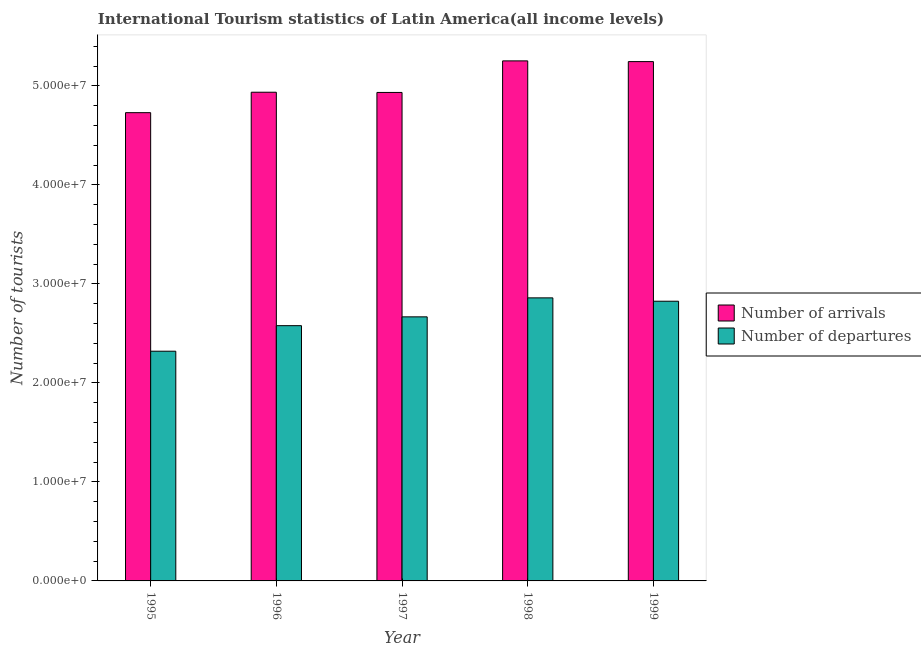What is the label of the 4th group of bars from the left?
Your response must be concise. 1998. What is the number of tourist departures in 1998?
Provide a succinct answer. 2.86e+07. Across all years, what is the maximum number of tourist arrivals?
Give a very brief answer. 5.25e+07. Across all years, what is the minimum number of tourist departures?
Your answer should be very brief. 2.32e+07. In which year was the number of tourist arrivals minimum?
Your response must be concise. 1995. What is the total number of tourist arrivals in the graph?
Provide a short and direct response. 2.51e+08. What is the difference between the number of tourist arrivals in 1995 and that in 1997?
Offer a very short reply. -2.04e+06. What is the difference between the number of tourist departures in 1996 and the number of tourist arrivals in 1995?
Your answer should be very brief. 2.58e+06. What is the average number of tourist arrivals per year?
Your answer should be compact. 5.02e+07. In the year 1998, what is the difference between the number of tourist departures and number of tourist arrivals?
Your answer should be very brief. 0. In how many years, is the number of tourist departures greater than 10000000?
Give a very brief answer. 5. What is the ratio of the number of tourist arrivals in 1998 to that in 1999?
Make the answer very short. 1. Is the number of tourist arrivals in 1995 less than that in 1999?
Make the answer very short. Yes. What is the difference between the highest and the second highest number of tourist arrivals?
Provide a short and direct response. 7.27e+04. What is the difference between the highest and the lowest number of tourist arrivals?
Provide a succinct answer. 5.23e+06. What does the 1st bar from the left in 1998 represents?
Your answer should be very brief. Number of arrivals. What does the 1st bar from the right in 1998 represents?
Your response must be concise. Number of departures. How many bars are there?
Offer a terse response. 10. What is the difference between two consecutive major ticks on the Y-axis?
Offer a very short reply. 1.00e+07. Are the values on the major ticks of Y-axis written in scientific E-notation?
Provide a short and direct response. Yes. Does the graph contain grids?
Provide a short and direct response. No. Where does the legend appear in the graph?
Make the answer very short. Center right. What is the title of the graph?
Give a very brief answer. International Tourism statistics of Latin America(all income levels). What is the label or title of the X-axis?
Your response must be concise. Year. What is the label or title of the Y-axis?
Provide a short and direct response. Number of tourists. What is the Number of tourists of Number of arrivals in 1995?
Your response must be concise. 4.73e+07. What is the Number of tourists of Number of departures in 1995?
Keep it short and to the point. 2.32e+07. What is the Number of tourists of Number of arrivals in 1996?
Make the answer very short. 4.94e+07. What is the Number of tourists in Number of departures in 1996?
Give a very brief answer. 2.58e+07. What is the Number of tourists of Number of arrivals in 1997?
Give a very brief answer. 4.93e+07. What is the Number of tourists in Number of departures in 1997?
Your response must be concise. 2.67e+07. What is the Number of tourists of Number of arrivals in 1998?
Keep it short and to the point. 5.25e+07. What is the Number of tourists in Number of departures in 1998?
Your answer should be compact. 2.86e+07. What is the Number of tourists of Number of arrivals in 1999?
Offer a very short reply. 5.25e+07. What is the Number of tourists of Number of departures in 1999?
Ensure brevity in your answer.  2.83e+07. Across all years, what is the maximum Number of tourists in Number of arrivals?
Give a very brief answer. 5.25e+07. Across all years, what is the maximum Number of tourists in Number of departures?
Offer a terse response. 2.86e+07. Across all years, what is the minimum Number of tourists of Number of arrivals?
Offer a terse response. 4.73e+07. Across all years, what is the minimum Number of tourists in Number of departures?
Keep it short and to the point. 2.32e+07. What is the total Number of tourists of Number of arrivals in the graph?
Keep it short and to the point. 2.51e+08. What is the total Number of tourists in Number of departures in the graph?
Offer a terse response. 1.33e+08. What is the difference between the Number of tourists of Number of arrivals in 1995 and that in 1996?
Your response must be concise. -2.06e+06. What is the difference between the Number of tourists in Number of departures in 1995 and that in 1996?
Make the answer very short. -2.58e+06. What is the difference between the Number of tourists of Number of arrivals in 1995 and that in 1997?
Provide a succinct answer. -2.04e+06. What is the difference between the Number of tourists in Number of departures in 1995 and that in 1997?
Ensure brevity in your answer.  -3.47e+06. What is the difference between the Number of tourists of Number of arrivals in 1995 and that in 1998?
Your answer should be very brief. -5.23e+06. What is the difference between the Number of tourists in Number of departures in 1995 and that in 1998?
Give a very brief answer. -5.39e+06. What is the difference between the Number of tourists of Number of arrivals in 1995 and that in 1999?
Keep it short and to the point. -5.16e+06. What is the difference between the Number of tourists in Number of departures in 1995 and that in 1999?
Provide a short and direct response. -5.05e+06. What is the difference between the Number of tourists in Number of arrivals in 1996 and that in 1997?
Provide a short and direct response. 2.15e+04. What is the difference between the Number of tourists of Number of departures in 1996 and that in 1997?
Your answer should be compact. -8.90e+05. What is the difference between the Number of tourists in Number of arrivals in 1996 and that in 1998?
Make the answer very short. -3.17e+06. What is the difference between the Number of tourists in Number of departures in 1996 and that in 1998?
Your answer should be very brief. -2.81e+06. What is the difference between the Number of tourists of Number of arrivals in 1996 and that in 1999?
Make the answer very short. -3.09e+06. What is the difference between the Number of tourists in Number of departures in 1996 and that in 1999?
Keep it short and to the point. -2.47e+06. What is the difference between the Number of tourists in Number of arrivals in 1997 and that in 1998?
Keep it short and to the point. -3.19e+06. What is the difference between the Number of tourists in Number of departures in 1997 and that in 1998?
Keep it short and to the point. -1.92e+06. What is the difference between the Number of tourists in Number of arrivals in 1997 and that in 1999?
Ensure brevity in your answer.  -3.12e+06. What is the difference between the Number of tourists in Number of departures in 1997 and that in 1999?
Provide a succinct answer. -1.58e+06. What is the difference between the Number of tourists of Number of arrivals in 1998 and that in 1999?
Keep it short and to the point. 7.27e+04. What is the difference between the Number of tourists in Number of departures in 1998 and that in 1999?
Provide a short and direct response. 3.40e+05. What is the difference between the Number of tourists of Number of arrivals in 1995 and the Number of tourists of Number of departures in 1996?
Offer a terse response. 2.15e+07. What is the difference between the Number of tourists in Number of arrivals in 1995 and the Number of tourists in Number of departures in 1997?
Your answer should be very brief. 2.06e+07. What is the difference between the Number of tourists of Number of arrivals in 1995 and the Number of tourists of Number of departures in 1998?
Provide a succinct answer. 1.87e+07. What is the difference between the Number of tourists in Number of arrivals in 1995 and the Number of tourists in Number of departures in 1999?
Offer a terse response. 1.90e+07. What is the difference between the Number of tourists in Number of arrivals in 1996 and the Number of tourists in Number of departures in 1997?
Offer a very short reply. 2.27e+07. What is the difference between the Number of tourists of Number of arrivals in 1996 and the Number of tourists of Number of departures in 1998?
Your answer should be compact. 2.08e+07. What is the difference between the Number of tourists of Number of arrivals in 1996 and the Number of tourists of Number of departures in 1999?
Keep it short and to the point. 2.11e+07. What is the difference between the Number of tourists of Number of arrivals in 1997 and the Number of tourists of Number of departures in 1998?
Keep it short and to the point. 2.08e+07. What is the difference between the Number of tourists of Number of arrivals in 1997 and the Number of tourists of Number of departures in 1999?
Provide a succinct answer. 2.11e+07. What is the difference between the Number of tourists of Number of arrivals in 1998 and the Number of tourists of Number of departures in 1999?
Ensure brevity in your answer.  2.43e+07. What is the average Number of tourists of Number of arrivals per year?
Ensure brevity in your answer.  5.02e+07. What is the average Number of tourists of Number of departures per year?
Your answer should be compact. 2.65e+07. In the year 1995, what is the difference between the Number of tourists in Number of arrivals and Number of tourists in Number of departures?
Offer a very short reply. 2.41e+07. In the year 1996, what is the difference between the Number of tourists of Number of arrivals and Number of tourists of Number of departures?
Your answer should be compact. 2.36e+07. In the year 1997, what is the difference between the Number of tourists in Number of arrivals and Number of tourists in Number of departures?
Keep it short and to the point. 2.27e+07. In the year 1998, what is the difference between the Number of tourists in Number of arrivals and Number of tourists in Number of departures?
Your answer should be compact. 2.39e+07. In the year 1999, what is the difference between the Number of tourists of Number of arrivals and Number of tourists of Number of departures?
Your answer should be very brief. 2.42e+07. What is the ratio of the Number of tourists in Number of arrivals in 1995 to that in 1996?
Your answer should be compact. 0.96. What is the ratio of the Number of tourists in Number of departures in 1995 to that in 1996?
Give a very brief answer. 0.9. What is the ratio of the Number of tourists in Number of arrivals in 1995 to that in 1997?
Keep it short and to the point. 0.96. What is the ratio of the Number of tourists of Number of departures in 1995 to that in 1997?
Ensure brevity in your answer.  0.87. What is the ratio of the Number of tourists in Number of arrivals in 1995 to that in 1998?
Your answer should be very brief. 0.9. What is the ratio of the Number of tourists in Number of departures in 1995 to that in 1998?
Give a very brief answer. 0.81. What is the ratio of the Number of tourists in Number of arrivals in 1995 to that in 1999?
Provide a short and direct response. 0.9. What is the ratio of the Number of tourists in Number of departures in 1995 to that in 1999?
Provide a succinct answer. 0.82. What is the ratio of the Number of tourists of Number of departures in 1996 to that in 1997?
Offer a terse response. 0.97. What is the ratio of the Number of tourists in Number of arrivals in 1996 to that in 1998?
Your response must be concise. 0.94. What is the ratio of the Number of tourists of Number of departures in 1996 to that in 1998?
Provide a succinct answer. 0.9. What is the ratio of the Number of tourists in Number of arrivals in 1996 to that in 1999?
Offer a terse response. 0.94. What is the ratio of the Number of tourists in Number of departures in 1996 to that in 1999?
Give a very brief answer. 0.91. What is the ratio of the Number of tourists of Number of arrivals in 1997 to that in 1998?
Provide a short and direct response. 0.94. What is the ratio of the Number of tourists of Number of departures in 1997 to that in 1998?
Keep it short and to the point. 0.93. What is the ratio of the Number of tourists of Number of arrivals in 1997 to that in 1999?
Provide a succinct answer. 0.94. What is the ratio of the Number of tourists in Number of departures in 1997 to that in 1999?
Offer a very short reply. 0.94. What is the difference between the highest and the second highest Number of tourists of Number of arrivals?
Keep it short and to the point. 7.27e+04. What is the difference between the highest and the second highest Number of tourists of Number of departures?
Give a very brief answer. 3.40e+05. What is the difference between the highest and the lowest Number of tourists of Number of arrivals?
Your response must be concise. 5.23e+06. What is the difference between the highest and the lowest Number of tourists of Number of departures?
Provide a short and direct response. 5.39e+06. 